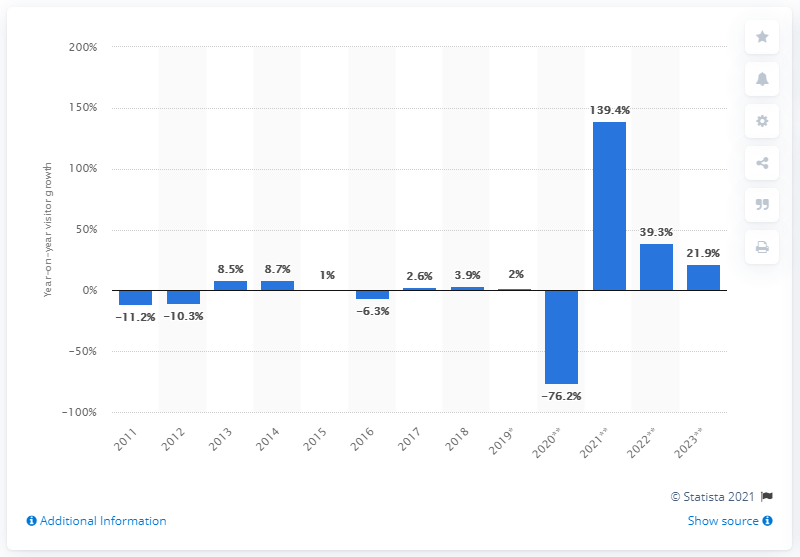Outline some significant characteristics in this image. In 2018, the number of outbound visitors from the Middle East decreased by 3.9% compared to the previous year. 